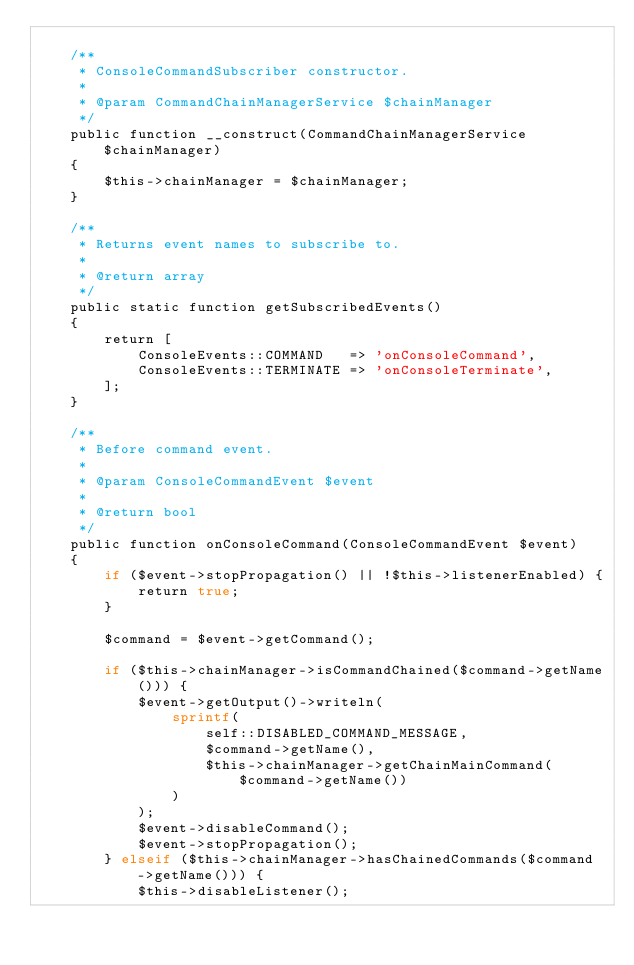<code> <loc_0><loc_0><loc_500><loc_500><_PHP_>
    /**
     * ConsoleCommandSubscriber constructor.
     *
     * @param CommandChainManagerService $chainManager
     */
    public function __construct(CommandChainManagerService $chainManager)
    {
        $this->chainManager = $chainManager;
    }

    /**
     * Returns event names to subscribe to.
     *
     * @return array
     */
    public static function getSubscribedEvents()
    {
        return [
            ConsoleEvents::COMMAND   => 'onConsoleCommand',
            ConsoleEvents::TERMINATE => 'onConsoleTerminate',
        ];
    }

    /**
     * Before command event.
     *
     * @param ConsoleCommandEvent $event
     *
     * @return bool
     */
    public function onConsoleCommand(ConsoleCommandEvent $event)
    {
        if ($event->stopPropagation() || !$this->listenerEnabled) {
            return true;
        }

        $command = $event->getCommand();

        if ($this->chainManager->isCommandChained($command->getName())) {
            $event->getOutput()->writeln(
                sprintf(
                    self::DISABLED_COMMAND_MESSAGE,
                    $command->getName(),
                    $this->chainManager->getChainMainCommand($command->getName())
                )
            );
            $event->disableCommand();
            $event->stopPropagation();
        } elseif ($this->chainManager->hasChainedCommands($command->getName())) {
            $this->disableListener();</code> 